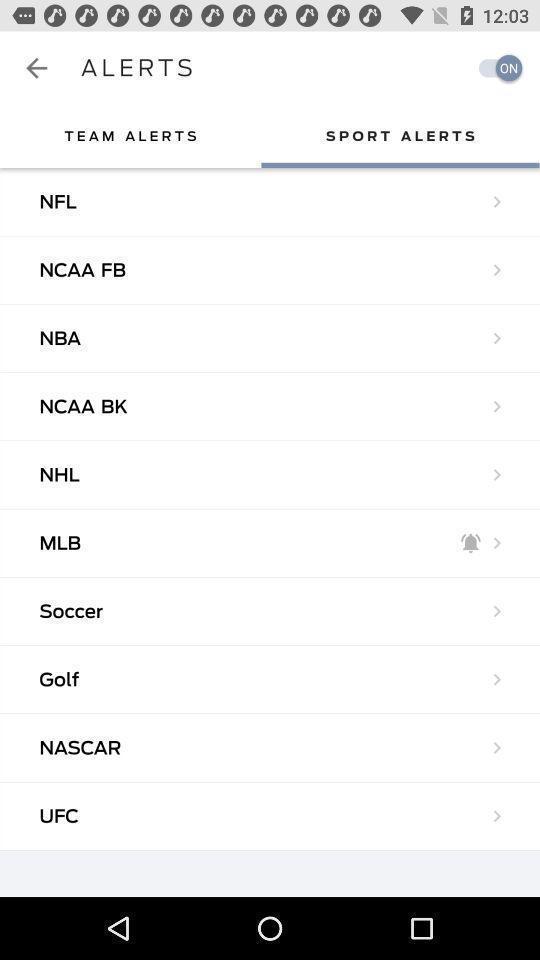Provide a detailed account of this screenshot. Screen displaying the list of sport alerts. 